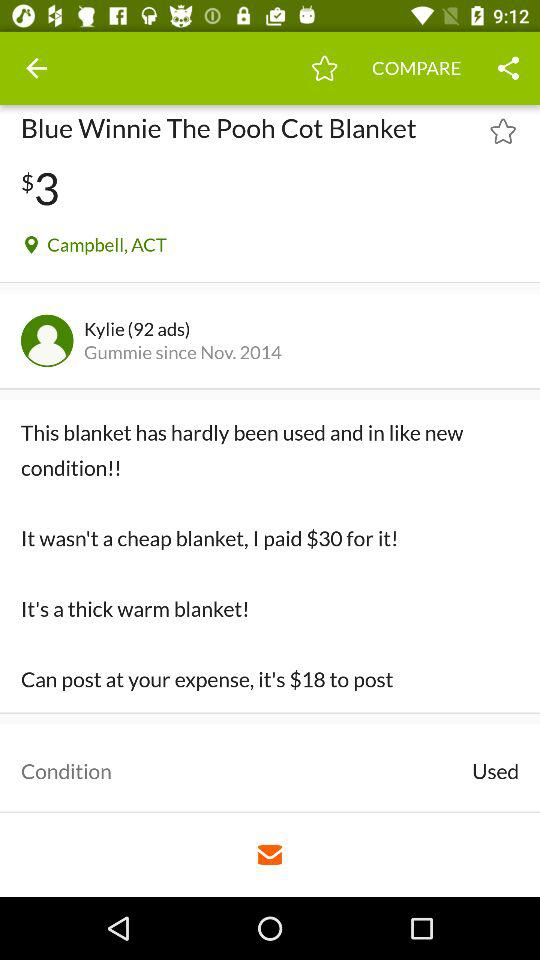How much does the user want for the blanket?
Answer the question using a single word or phrase. $3 